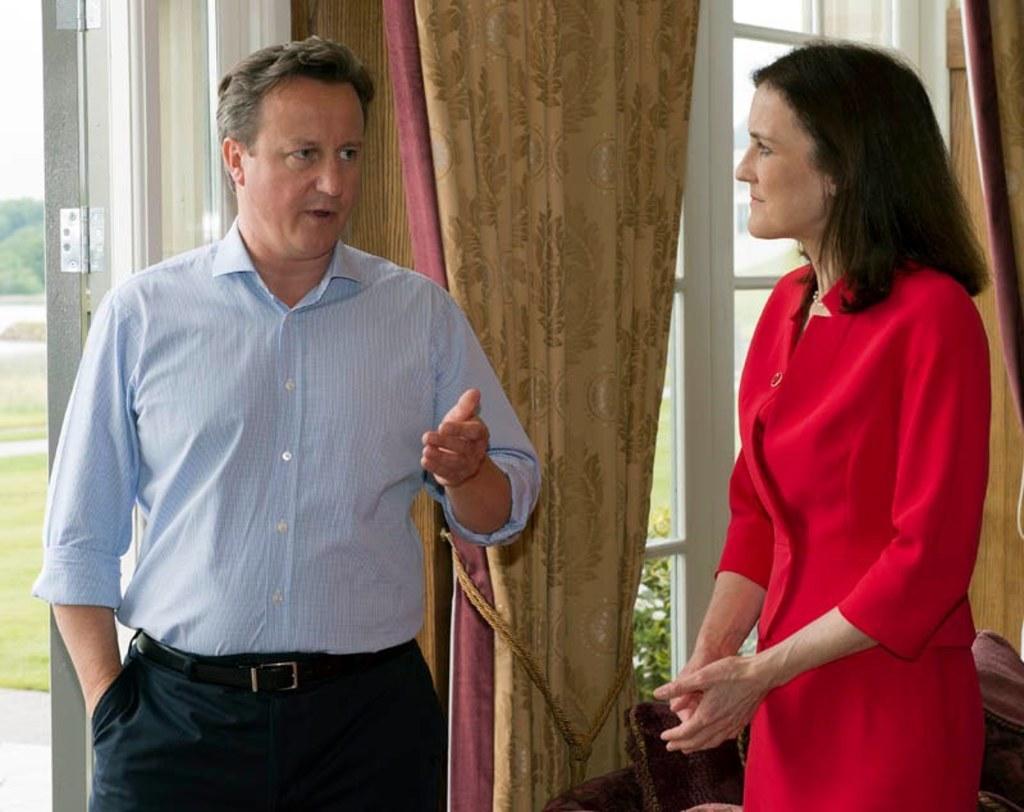How would you summarize this image in a sentence or two? In this picture there is a man and a woman in the image and there are windows, curtain, and a door in the background area of the image and there is greenery outside the window. 